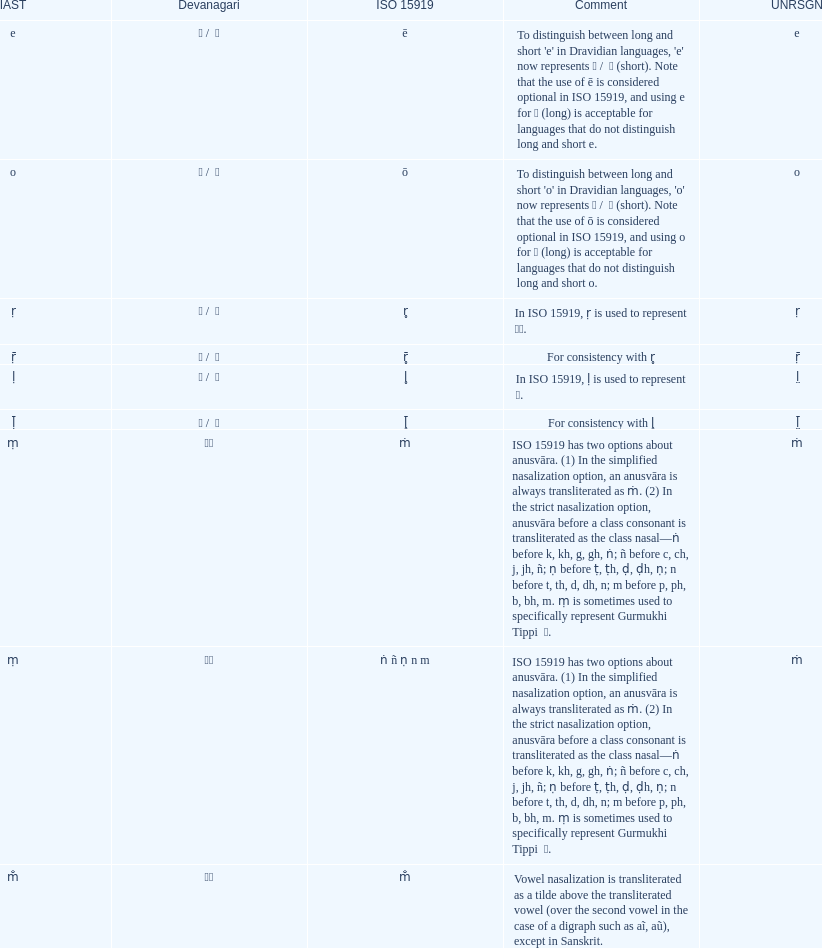What unrsgn is mentioned before the o? E. 